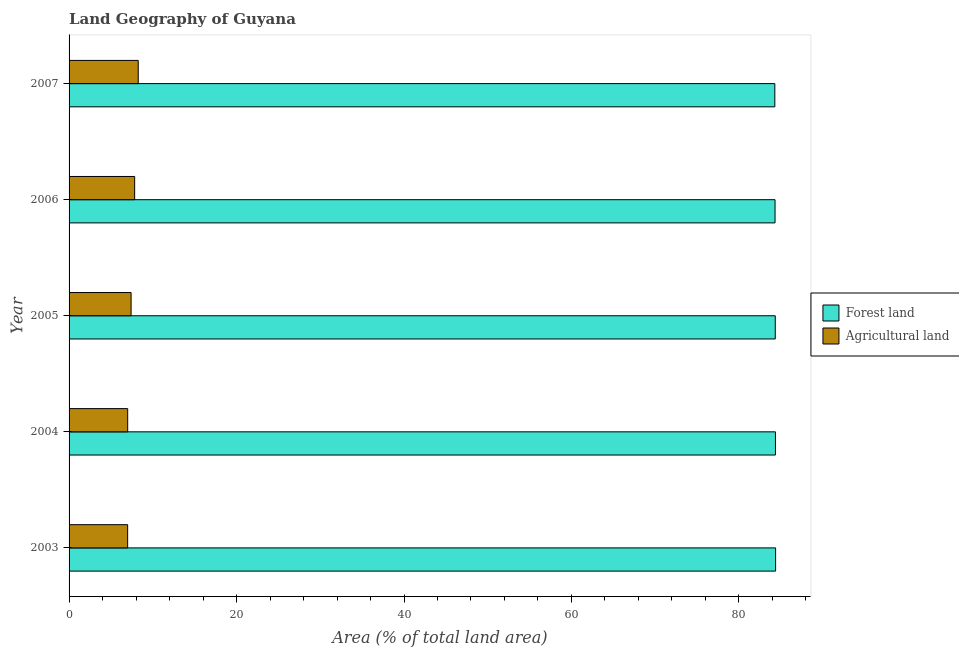How many different coloured bars are there?
Your answer should be compact. 2. How many groups of bars are there?
Your answer should be compact. 5. Are the number of bars per tick equal to the number of legend labels?
Give a very brief answer. Yes. Are the number of bars on each tick of the Y-axis equal?
Provide a succinct answer. Yes. How many bars are there on the 4th tick from the bottom?
Make the answer very short. 2. What is the label of the 1st group of bars from the top?
Give a very brief answer. 2007. In how many cases, is the number of bars for a given year not equal to the number of legend labels?
Make the answer very short. 0. What is the percentage of land area under agriculture in 2003?
Give a very brief answer. 7. Across all years, what is the maximum percentage of land area under forests?
Offer a terse response. 84.38. Across all years, what is the minimum percentage of land area under agriculture?
Provide a short and direct response. 7. What is the total percentage of land area under agriculture in the graph?
Keep it short and to the point. 37.5. What is the difference between the percentage of land area under agriculture in 2003 and that in 2004?
Ensure brevity in your answer.  -0.01. What is the difference between the percentage of land area under forests in 2004 and the percentage of land area under agriculture in 2003?
Your response must be concise. 77.36. What is the average percentage of land area under agriculture per year?
Provide a succinct answer. 7.5. In the year 2007, what is the difference between the percentage of land area under forests and percentage of land area under agriculture?
Your answer should be very brief. 76.03. What is the ratio of the percentage of land area under forests in 2004 to that in 2007?
Your response must be concise. 1. Is the difference between the percentage of land area under forests in 2005 and 2006 greater than the difference between the percentage of land area under agriculture in 2005 and 2006?
Offer a terse response. Yes. What is the difference between the highest and the second highest percentage of land area under agriculture?
Offer a very short reply. 0.43. What is the difference between the highest and the lowest percentage of land area under agriculture?
Provide a short and direct response. 1.27. Is the sum of the percentage of land area under forests in 2003 and 2004 greater than the maximum percentage of land area under agriculture across all years?
Your answer should be very brief. Yes. What does the 1st bar from the top in 2005 represents?
Keep it short and to the point. Agricultural land. What does the 2nd bar from the bottom in 2004 represents?
Offer a terse response. Agricultural land. How many bars are there?
Your response must be concise. 10. Are all the bars in the graph horizontal?
Provide a succinct answer. Yes. Does the graph contain any zero values?
Provide a short and direct response. No. Where does the legend appear in the graph?
Your answer should be compact. Center right. How many legend labels are there?
Your response must be concise. 2. How are the legend labels stacked?
Give a very brief answer. Vertical. What is the title of the graph?
Your answer should be very brief. Land Geography of Guyana. Does "Adolescent fertility rate" appear as one of the legend labels in the graph?
Your response must be concise. No. What is the label or title of the X-axis?
Make the answer very short. Area (% of total land area). What is the Area (% of total land area) in Forest land in 2003?
Your answer should be compact. 84.38. What is the Area (% of total land area) of Agricultural land in 2003?
Make the answer very short. 7. What is the Area (% of total land area) in Forest land in 2004?
Your response must be concise. 84.36. What is the Area (% of total land area) in Agricultural land in 2004?
Make the answer very short. 7. What is the Area (% of total land area) in Forest land in 2005?
Offer a terse response. 84.34. What is the Area (% of total land area) of Agricultural land in 2005?
Provide a short and direct response. 7.41. What is the Area (% of total land area) in Forest land in 2006?
Your response must be concise. 84.31. What is the Area (% of total land area) of Agricultural land in 2006?
Your answer should be very brief. 7.83. What is the Area (% of total land area) of Forest land in 2007?
Your answer should be compact. 84.29. What is the Area (% of total land area) in Agricultural land in 2007?
Your answer should be very brief. 8.26. Across all years, what is the maximum Area (% of total land area) of Forest land?
Offer a very short reply. 84.38. Across all years, what is the maximum Area (% of total land area) in Agricultural land?
Make the answer very short. 8.26. Across all years, what is the minimum Area (% of total land area) of Forest land?
Offer a terse response. 84.29. Across all years, what is the minimum Area (% of total land area) of Agricultural land?
Give a very brief answer. 7. What is the total Area (% of total land area) of Forest land in the graph?
Your response must be concise. 421.67. What is the total Area (% of total land area) of Agricultural land in the graph?
Offer a very short reply. 37.5. What is the difference between the Area (% of total land area) of Forest land in 2003 and that in 2004?
Your answer should be compact. 0.02. What is the difference between the Area (% of total land area) in Agricultural land in 2003 and that in 2004?
Offer a very short reply. -0.01. What is the difference between the Area (% of total land area) of Forest land in 2003 and that in 2005?
Offer a very short reply. 0.04. What is the difference between the Area (% of total land area) in Agricultural land in 2003 and that in 2005?
Offer a very short reply. -0.41. What is the difference between the Area (% of total land area) in Forest land in 2003 and that in 2006?
Your answer should be compact. 0.07. What is the difference between the Area (% of total land area) in Agricultural land in 2003 and that in 2006?
Offer a terse response. -0.84. What is the difference between the Area (% of total land area) of Forest land in 2003 and that in 2007?
Keep it short and to the point. 0.09. What is the difference between the Area (% of total land area) in Agricultural land in 2003 and that in 2007?
Your response must be concise. -1.26. What is the difference between the Area (% of total land area) in Forest land in 2004 and that in 2005?
Give a very brief answer. 0.02. What is the difference between the Area (% of total land area) of Agricultural land in 2004 and that in 2005?
Offer a terse response. -0.41. What is the difference between the Area (% of total land area) of Forest land in 2004 and that in 2006?
Make the answer very short. 0.05. What is the difference between the Area (% of total land area) in Agricultural land in 2004 and that in 2006?
Provide a succinct answer. -0.83. What is the difference between the Area (% of total land area) of Forest land in 2004 and that in 2007?
Give a very brief answer. 0.07. What is the difference between the Area (% of total land area) of Agricultural land in 2004 and that in 2007?
Ensure brevity in your answer.  -1.26. What is the difference between the Area (% of total land area) of Forest land in 2005 and that in 2006?
Give a very brief answer. 0.03. What is the difference between the Area (% of total land area) in Agricultural land in 2005 and that in 2006?
Your response must be concise. -0.43. What is the difference between the Area (% of total land area) of Forest land in 2005 and that in 2007?
Your answer should be very brief. 0.05. What is the difference between the Area (% of total land area) of Agricultural land in 2005 and that in 2007?
Your response must be concise. -0.85. What is the difference between the Area (% of total land area) in Forest land in 2006 and that in 2007?
Keep it short and to the point. 0.03. What is the difference between the Area (% of total land area) in Agricultural land in 2006 and that in 2007?
Ensure brevity in your answer.  -0.43. What is the difference between the Area (% of total land area) in Forest land in 2003 and the Area (% of total land area) in Agricultural land in 2004?
Ensure brevity in your answer.  77.38. What is the difference between the Area (% of total land area) of Forest land in 2003 and the Area (% of total land area) of Agricultural land in 2005?
Your answer should be very brief. 76.97. What is the difference between the Area (% of total land area) of Forest land in 2003 and the Area (% of total land area) of Agricultural land in 2006?
Keep it short and to the point. 76.55. What is the difference between the Area (% of total land area) of Forest land in 2003 and the Area (% of total land area) of Agricultural land in 2007?
Offer a terse response. 76.12. What is the difference between the Area (% of total land area) of Forest land in 2004 and the Area (% of total land area) of Agricultural land in 2005?
Keep it short and to the point. 76.95. What is the difference between the Area (% of total land area) in Forest land in 2004 and the Area (% of total land area) in Agricultural land in 2006?
Your response must be concise. 76.53. What is the difference between the Area (% of total land area) of Forest land in 2004 and the Area (% of total land area) of Agricultural land in 2007?
Ensure brevity in your answer.  76.1. What is the difference between the Area (% of total land area) of Forest land in 2005 and the Area (% of total land area) of Agricultural land in 2006?
Keep it short and to the point. 76.5. What is the difference between the Area (% of total land area) of Forest land in 2005 and the Area (% of total land area) of Agricultural land in 2007?
Provide a short and direct response. 76.08. What is the difference between the Area (% of total land area) of Forest land in 2006 and the Area (% of total land area) of Agricultural land in 2007?
Your answer should be compact. 76.05. What is the average Area (% of total land area) of Forest land per year?
Your response must be concise. 84.33. What is the average Area (% of total land area) in Agricultural land per year?
Your answer should be very brief. 7.5. In the year 2003, what is the difference between the Area (% of total land area) in Forest land and Area (% of total land area) in Agricultural land?
Provide a short and direct response. 77.38. In the year 2004, what is the difference between the Area (% of total land area) of Forest land and Area (% of total land area) of Agricultural land?
Give a very brief answer. 77.36. In the year 2005, what is the difference between the Area (% of total land area) in Forest land and Area (% of total land area) in Agricultural land?
Ensure brevity in your answer.  76.93. In the year 2006, what is the difference between the Area (% of total land area) of Forest land and Area (% of total land area) of Agricultural land?
Make the answer very short. 76.48. In the year 2007, what is the difference between the Area (% of total land area) of Forest land and Area (% of total land area) of Agricultural land?
Your answer should be very brief. 76.03. What is the ratio of the Area (% of total land area) of Forest land in 2003 to that in 2004?
Provide a short and direct response. 1. What is the ratio of the Area (% of total land area) of Agricultural land in 2003 to that in 2004?
Your answer should be very brief. 1. What is the ratio of the Area (% of total land area) of Forest land in 2003 to that in 2005?
Make the answer very short. 1. What is the ratio of the Area (% of total land area) in Agricultural land in 2003 to that in 2006?
Your answer should be very brief. 0.89. What is the ratio of the Area (% of total land area) of Agricultural land in 2003 to that in 2007?
Give a very brief answer. 0.85. What is the ratio of the Area (% of total land area) of Agricultural land in 2004 to that in 2005?
Give a very brief answer. 0.95. What is the ratio of the Area (% of total land area) of Agricultural land in 2004 to that in 2006?
Offer a terse response. 0.89. What is the ratio of the Area (% of total land area) in Forest land in 2004 to that in 2007?
Keep it short and to the point. 1. What is the ratio of the Area (% of total land area) in Agricultural land in 2004 to that in 2007?
Your response must be concise. 0.85. What is the ratio of the Area (% of total land area) of Forest land in 2005 to that in 2006?
Give a very brief answer. 1. What is the ratio of the Area (% of total land area) in Agricultural land in 2005 to that in 2006?
Keep it short and to the point. 0.95. What is the ratio of the Area (% of total land area) in Agricultural land in 2005 to that in 2007?
Offer a terse response. 0.9. What is the ratio of the Area (% of total land area) in Agricultural land in 2006 to that in 2007?
Provide a short and direct response. 0.95. What is the difference between the highest and the second highest Area (% of total land area) in Forest land?
Provide a short and direct response. 0.02. What is the difference between the highest and the second highest Area (% of total land area) of Agricultural land?
Provide a succinct answer. 0.43. What is the difference between the highest and the lowest Area (% of total land area) in Forest land?
Your answer should be very brief. 0.09. What is the difference between the highest and the lowest Area (% of total land area) of Agricultural land?
Keep it short and to the point. 1.26. 